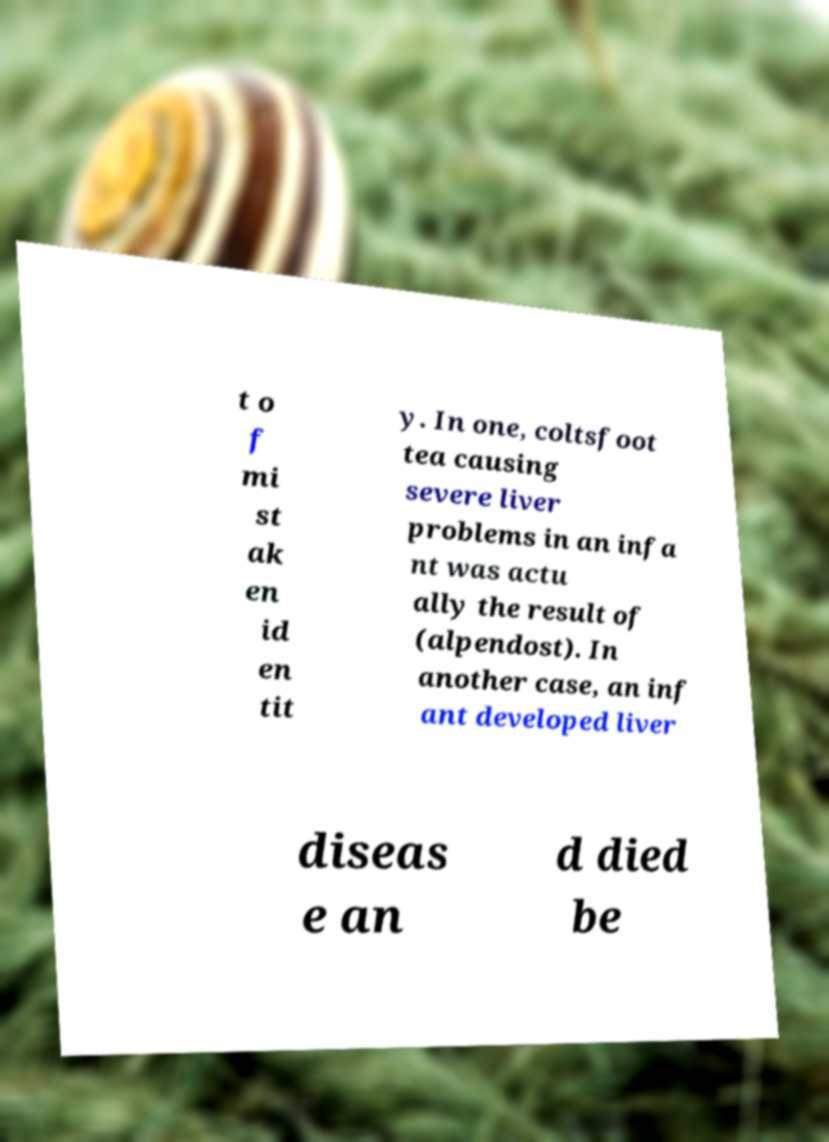What messages or text are displayed in this image? I need them in a readable, typed format. t o f mi st ak en id en tit y. In one, coltsfoot tea causing severe liver problems in an infa nt was actu ally the result of (alpendost). In another case, an inf ant developed liver diseas e an d died be 